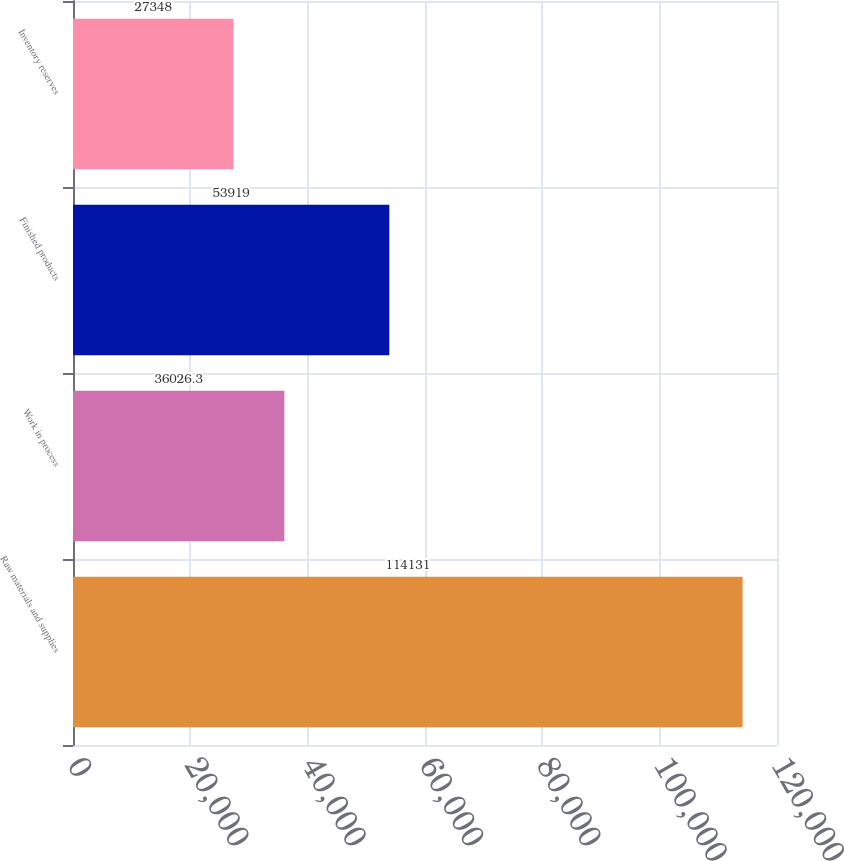Convert chart. <chart><loc_0><loc_0><loc_500><loc_500><bar_chart><fcel>Raw materials and supplies<fcel>Work in process<fcel>Finished products<fcel>Inventory reserves<nl><fcel>114131<fcel>36026.3<fcel>53919<fcel>27348<nl></chart> 